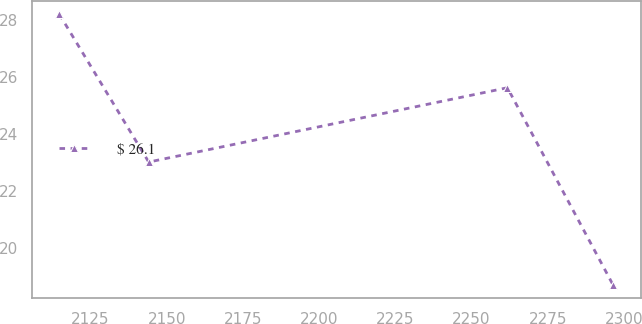Convert chart to OTSL. <chart><loc_0><loc_0><loc_500><loc_500><line_chart><ecel><fcel>$ 26.1<nl><fcel>2114.79<fcel>28.19<nl><fcel>2144.1<fcel>23.02<nl><fcel>2261.74<fcel>25.62<nl><fcel>2296.39<fcel>18.72<nl></chart> 